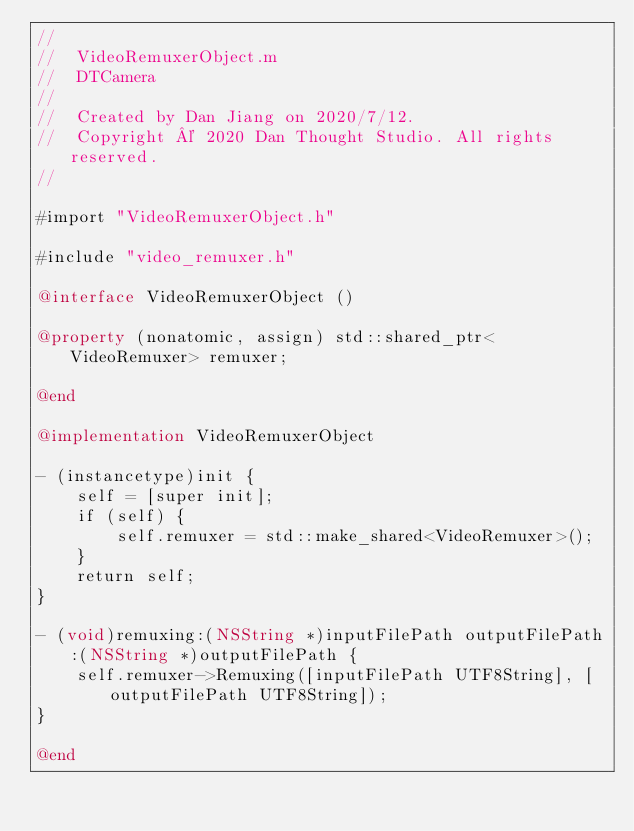Convert code to text. <code><loc_0><loc_0><loc_500><loc_500><_ObjectiveC_>//
//  VideoRemuxerObject.m
//  DTCamera
//
//  Created by Dan Jiang on 2020/7/12.
//  Copyright © 2020 Dan Thought Studio. All rights reserved.
//

#import "VideoRemuxerObject.h"

#include "video_remuxer.h"

@interface VideoRemuxerObject ()

@property (nonatomic, assign) std::shared_ptr<VideoRemuxer> remuxer;

@end

@implementation VideoRemuxerObject

- (instancetype)init {
    self = [super init];
    if (self) {
        self.remuxer = std::make_shared<VideoRemuxer>();
    }
    return self;
}

- (void)remuxing:(NSString *)inputFilePath outputFilePath:(NSString *)outputFilePath {
    self.remuxer->Remuxing([inputFilePath UTF8String], [outputFilePath UTF8String]);
}

@end
</code> 